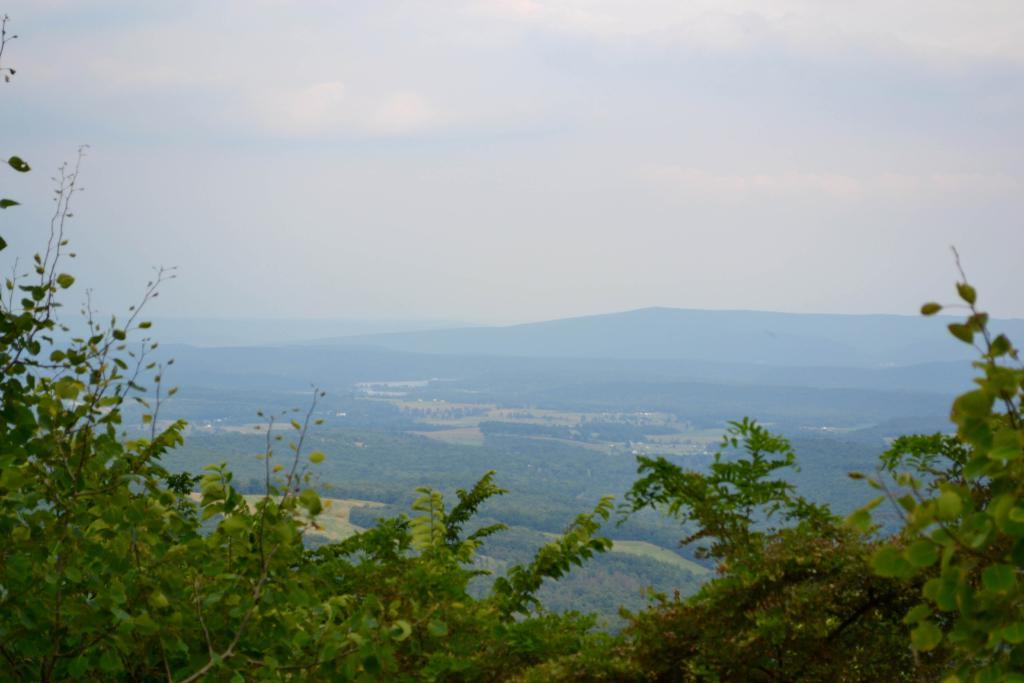What type of vegetation can be seen in the image? There are green color plants and trees in the image. What is visible in the background of the image? The sky is visible in the image. How would you describe the weather based on the appearance of the sky? The sky is cloudy, which suggests overcast or potentially rainy weather. What is the color of the sky in the image? The color of the sky is white. How does the grip of the tree affect the way it burns in the image? There is no tree burning in the image, and the grip of the tree is not mentioned in the provided facts. 